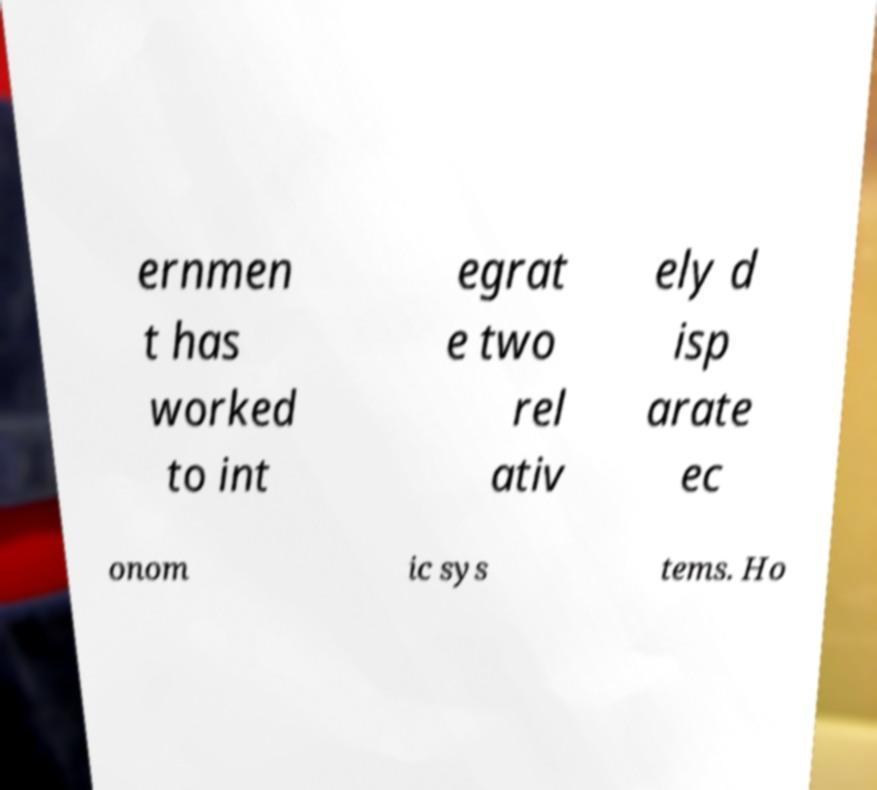Can you accurately transcribe the text from the provided image for me? ernmen t has worked to int egrat e two rel ativ ely d isp arate ec onom ic sys tems. Ho 